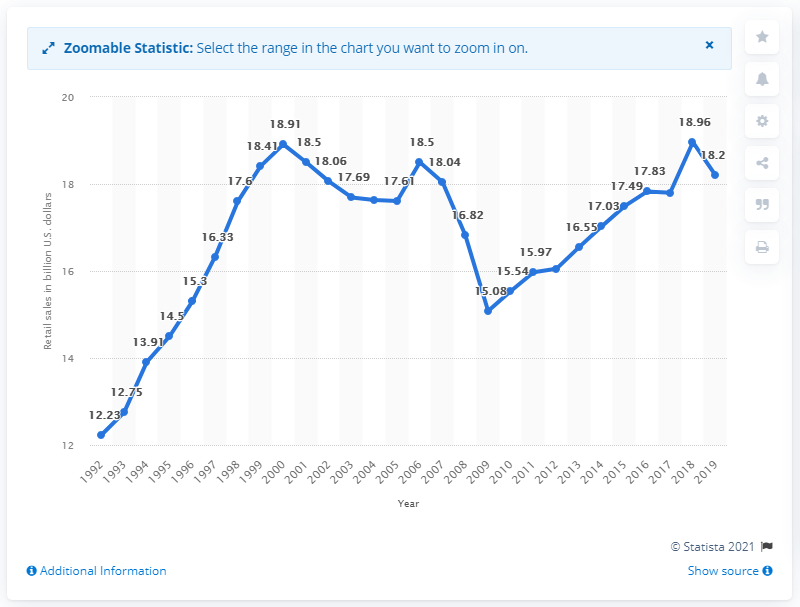List a handful of essential elements in this visual. The sales of a gift, novelty, and souvenir store from one year earlier were approximately 18.96. The sales of gift, novelty, and souvenir stores in 2019 were approximately 18.2... 